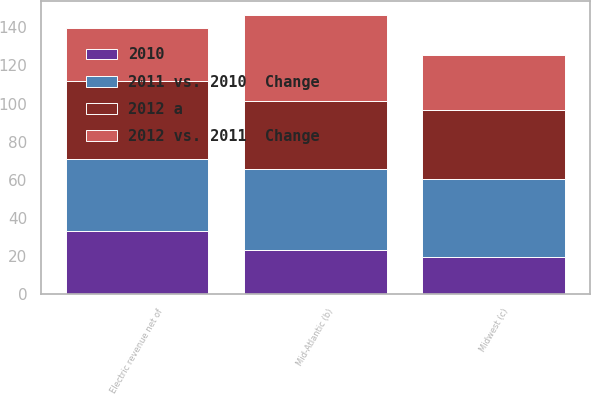Convert chart. <chart><loc_0><loc_0><loc_500><loc_500><stacked_bar_chart><ecel><fcel>Mid-Atlantic (b)<fcel>Midwest (c)<fcel>Electric revenue net of<nl><fcel>2012 vs. 2011  Change<fcel>44.6<fcel>29.02<fcel>27.45<nl><fcel>2012 a<fcel>35.99<fcel>35.99<fcel>41.07<nl><fcel>2010<fcel>23.1<fcel>19.4<fcel>33.2<nl><fcel>2011 vs. 2010  Change<fcel>42.48<fcel>40.98<fcel>37.62<nl></chart> 